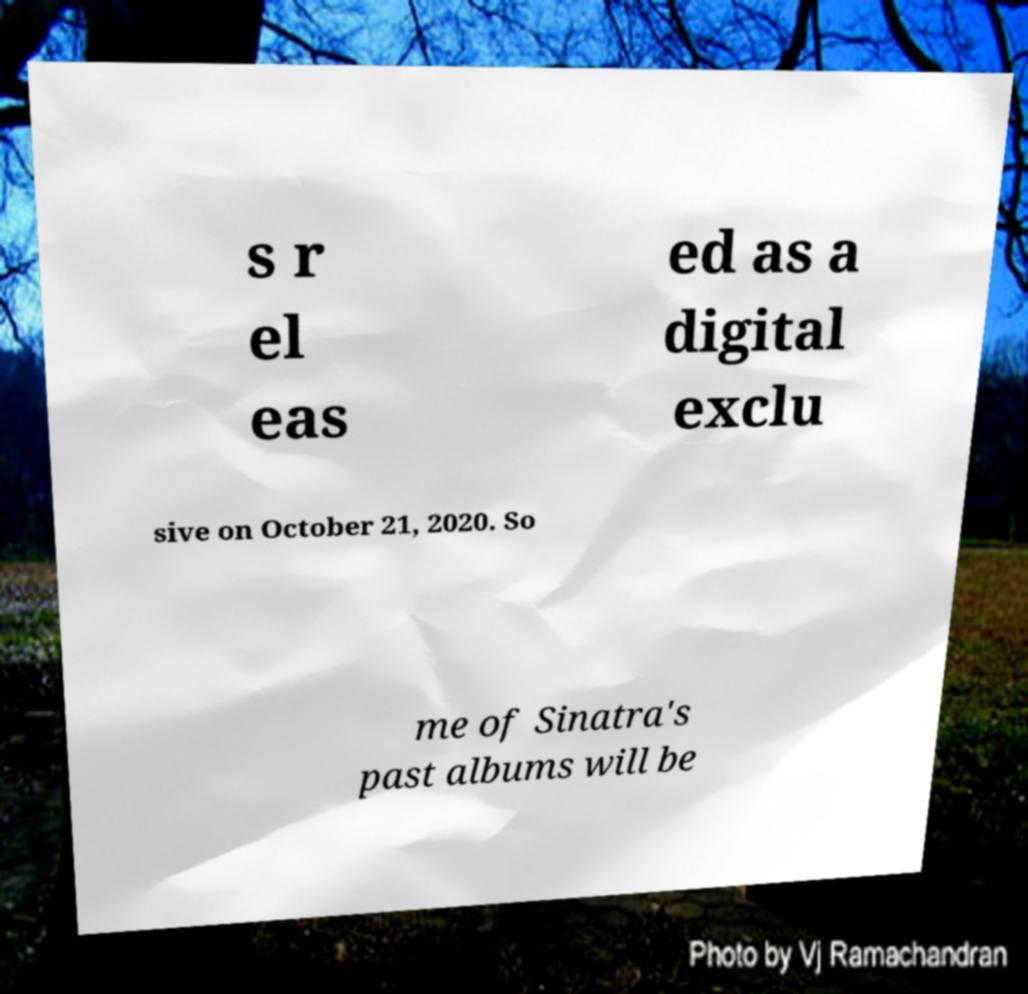Can you read and provide the text displayed in the image?This photo seems to have some interesting text. Can you extract and type it out for me? s r el eas ed as a digital exclu sive on October 21, 2020. So me of Sinatra's past albums will be 